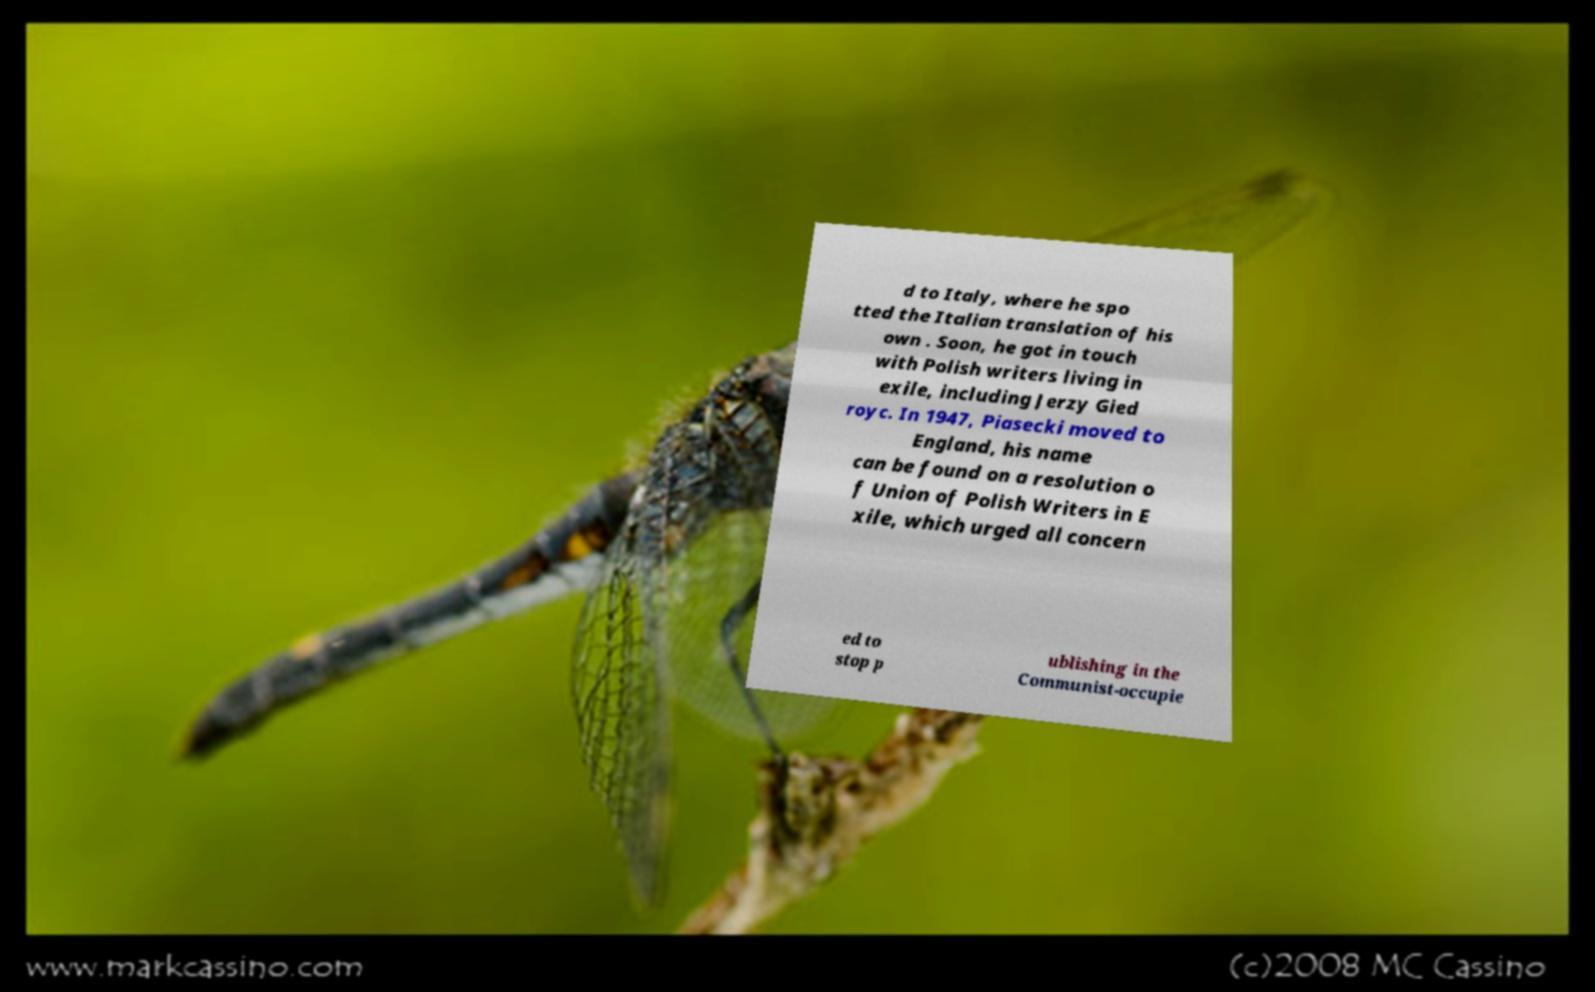I need the written content from this picture converted into text. Can you do that? d to Italy, where he spo tted the Italian translation of his own . Soon, he got in touch with Polish writers living in exile, including Jerzy Gied royc. In 1947, Piasecki moved to England, his name can be found on a resolution o f Union of Polish Writers in E xile, which urged all concern ed to stop p ublishing in the Communist-occupie 